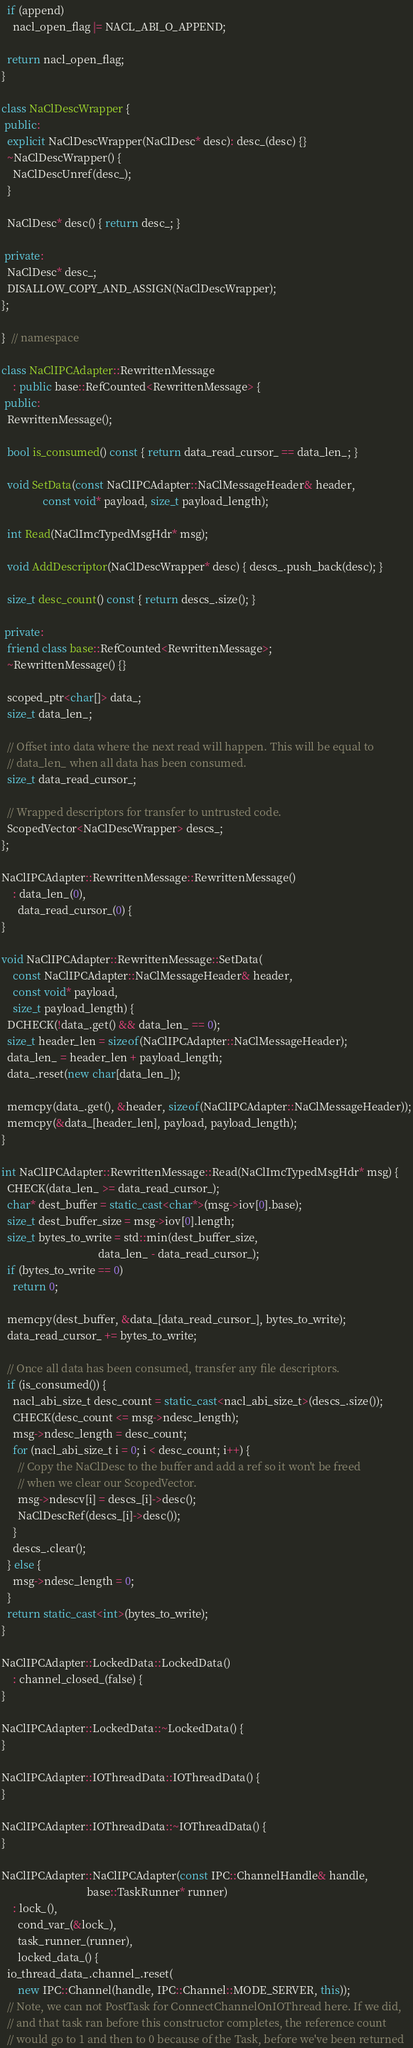Convert code to text. <code><loc_0><loc_0><loc_500><loc_500><_C++_>  if (append)
    nacl_open_flag |= NACL_ABI_O_APPEND;

  return nacl_open_flag;
}

class NaClDescWrapper {
 public:
  explicit NaClDescWrapper(NaClDesc* desc): desc_(desc) {}
  ~NaClDescWrapper() {
    NaClDescUnref(desc_);
  }

  NaClDesc* desc() { return desc_; }

 private:
  NaClDesc* desc_;
  DISALLOW_COPY_AND_ASSIGN(NaClDescWrapper);
};

}  // namespace

class NaClIPCAdapter::RewrittenMessage
    : public base::RefCounted<RewrittenMessage> {
 public:
  RewrittenMessage();

  bool is_consumed() const { return data_read_cursor_ == data_len_; }

  void SetData(const NaClIPCAdapter::NaClMessageHeader& header,
               const void* payload, size_t payload_length);

  int Read(NaClImcTypedMsgHdr* msg);

  void AddDescriptor(NaClDescWrapper* desc) { descs_.push_back(desc); }

  size_t desc_count() const { return descs_.size(); }

 private:
  friend class base::RefCounted<RewrittenMessage>;
  ~RewrittenMessage() {}

  scoped_ptr<char[]> data_;
  size_t data_len_;

  // Offset into data where the next read will happen. This will be equal to
  // data_len_ when all data has been consumed.
  size_t data_read_cursor_;

  // Wrapped descriptors for transfer to untrusted code.
  ScopedVector<NaClDescWrapper> descs_;
};

NaClIPCAdapter::RewrittenMessage::RewrittenMessage()
    : data_len_(0),
      data_read_cursor_(0) {
}

void NaClIPCAdapter::RewrittenMessage::SetData(
    const NaClIPCAdapter::NaClMessageHeader& header,
    const void* payload,
    size_t payload_length) {
  DCHECK(!data_.get() && data_len_ == 0);
  size_t header_len = sizeof(NaClIPCAdapter::NaClMessageHeader);
  data_len_ = header_len + payload_length;
  data_.reset(new char[data_len_]);

  memcpy(data_.get(), &header, sizeof(NaClIPCAdapter::NaClMessageHeader));
  memcpy(&data_[header_len], payload, payload_length);
}

int NaClIPCAdapter::RewrittenMessage::Read(NaClImcTypedMsgHdr* msg) {
  CHECK(data_len_ >= data_read_cursor_);
  char* dest_buffer = static_cast<char*>(msg->iov[0].base);
  size_t dest_buffer_size = msg->iov[0].length;
  size_t bytes_to_write = std::min(dest_buffer_size,
                                   data_len_ - data_read_cursor_);
  if (bytes_to_write == 0)
    return 0;

  memcpy(dest_buffer, &data_[data_read_cursor_], bytes_to_write);
  data_read_cursor_ += bytes_to_write;

  // Once all data has been consumed, transfer any file descriptors.
  if (is_consumed()) {
    nacl_abi_size_t desc_count = static_cast<nacl_abi_size_t>(descs_.size());
    CHECK(desc_count <= msg->ndesc_length);
    msg->ndesc_length = desc_count;
    for (nacl_abi_size_t i = 0; i < desc_count; i++) {
      // Copy the NaClDesc to the buffer and add a ref so it won't be freed
      // when we clear our ScopedVector.
      msg->ndescv[i] = descs_[i]->desc();
      NaClDescRef(descs_[i]->desc());
    }
    descs_.clear();
  } else {
    msg->ndesc_length = 0;
  }
  return static_cast<int>(bytes_to_write);
}

NaClIPCAdapter::LockedData::LockedData()
    : channel_closed_(false) {
}

NaClIPCAdapter::LockedData::~LockedData() {
}

NaClIPCAdapter::IOThreadData::IOThreadData() {
}

NaClIPCAdapter::IOThreadData::~IOThreadData() {
}

NaClIPCAdapter::NaClIPCAdapter(const IPC::ChannelHandle& handle,
                               base::TaskRunner* runner)
    : lock_(),
      cond_var_(&lock_),
      task_runner_(runner),
      locked_data_() {
  io_thread_data_.channel_.reset(
      new IPC::Channel(handle, IPC::Channel::MODE_SERVER, this));
  // Note, we can not PostTask for ConnectChannelOnIOThread here. If we did,
  // and that task ran before this constructor completes, the reference count
  // would go to 1 and then to 0 because of the Task, before we've been returned</code> 